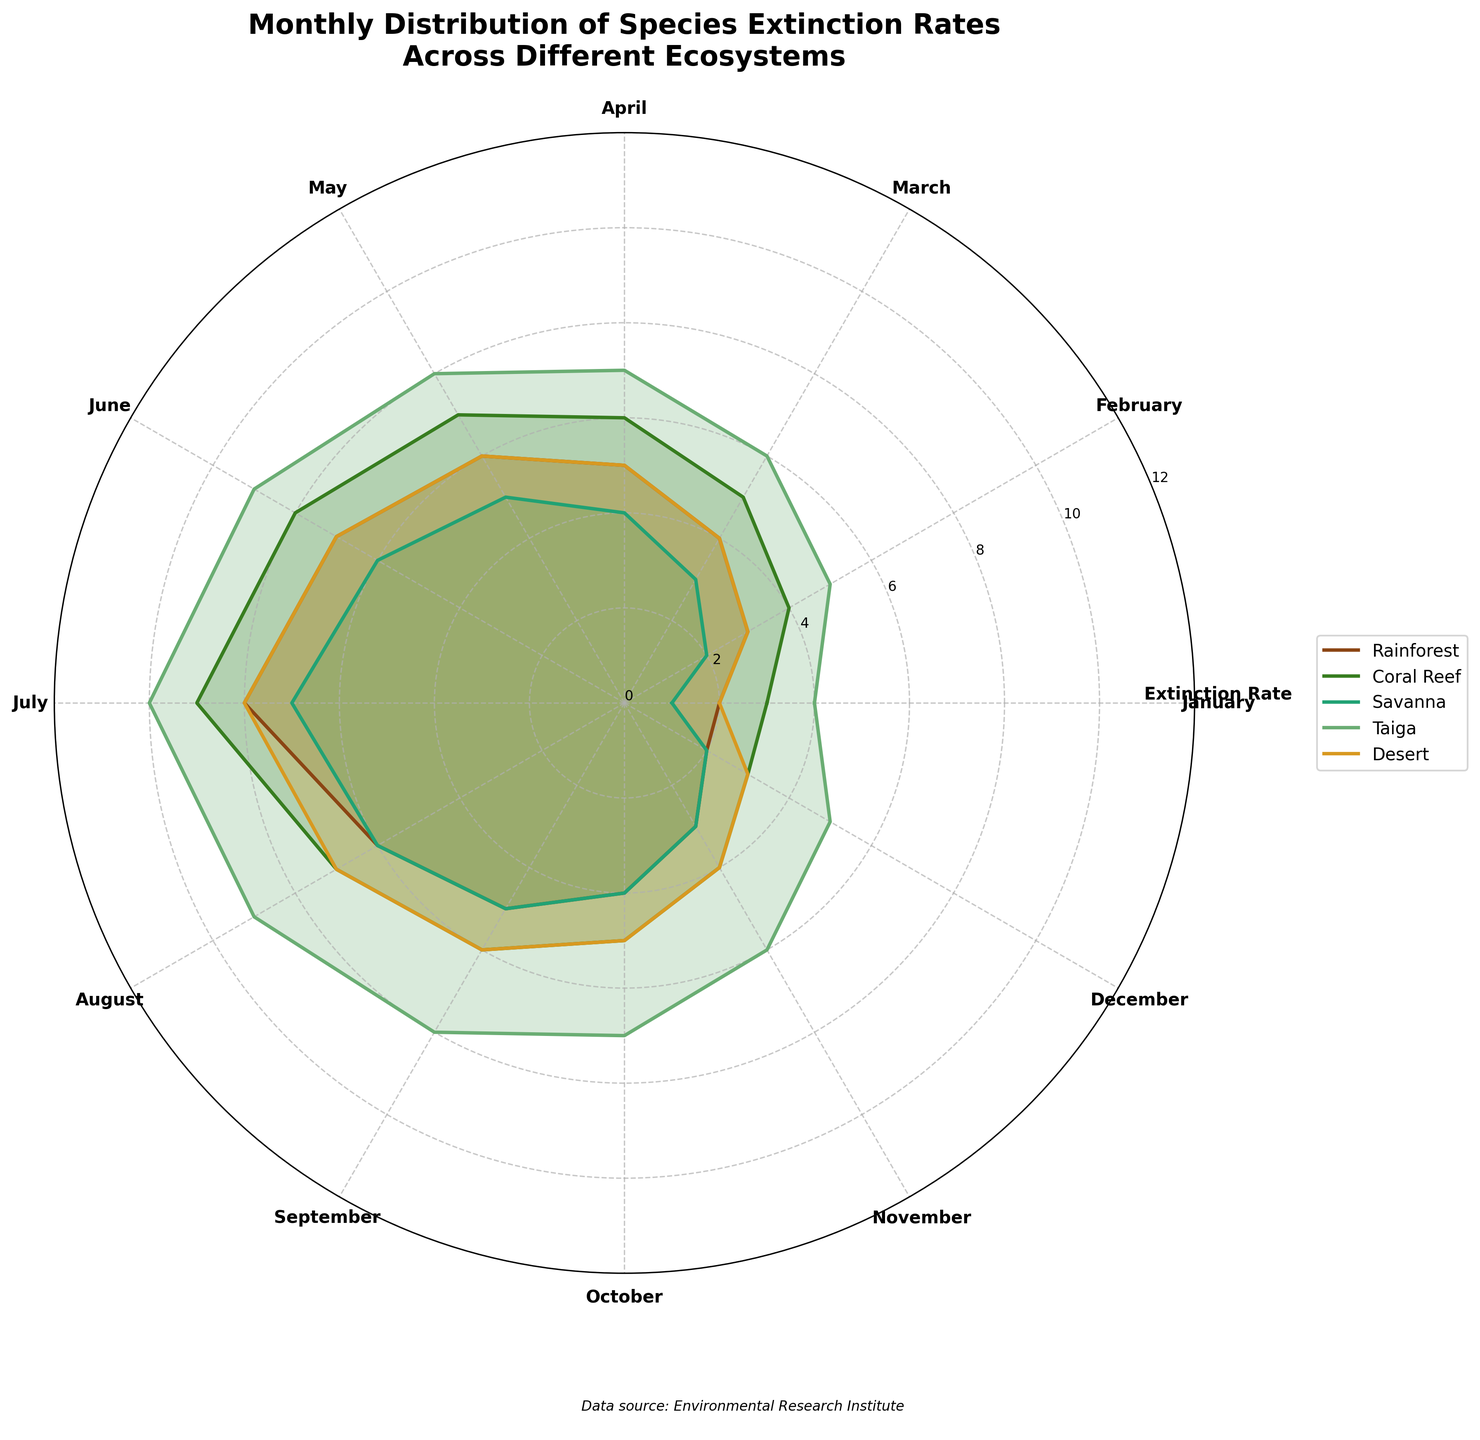What is the title of the figure? The title is typically found at the top of the figure and provides a broad description of what the graph represents. In this case, it is about the monthly distribution of species extinction rates across different ecosystems.
Answer: Monthly Distribution of Species Extinction Rates Across Different Ecosystems What is the maximum extinction rate recorded for the Taiga ecosystem? Look for the Taiga data series on the rose chart and identify the highest point on the radial axis. The maximum value represents the highest extinction rate.
Answer: 10 Which ecosystem has the lowest extinction rate in January? Compare the data points for January across all ecosystems. The ecosystem with the smallest radial extent in January has the lowest extinction rate.
Answer: Savanna In which month do both Rainforest and Coral Reef ecosystems show the same extinction rate? Compare the lines or filled areas for both Rainforest and Coral Reef ecosystems across all months and note if any intersect or overlap at the same radial distance from the center.
Answer: December What's the average extinction rate for the Rainforest ecosystem over the year? To find the average, sum the extinction rates for the Rainforest ecosystem across all months and divide by 12 (the number of months). The calculation is (2 + 3 + 4 + 5 + 6 + 7 + 8 + 6 + 5 + 4 + 3 + 2) / 12.
Answer: 4.75 In which month is the extinction rate highest for all ecosystems combined? For this, you would identify the month where the combined radial extents of all ecosystems are collectively the largest on the plot. Highest extinction rates are typically shown with the largest aggregate visual representations.
Answer: July Which ecosystem shows the greatest fluctuating extinction rates throughout the year? Compare the range of extinction rates for each ecosystem by looking at the difference between their maximum and minimum values. The ecosystem with the widest spread indicates the greatest fluctuation.
Answer: Taiga How do the extinction rates in Coral Reefs and Savannas compare in April? Observe the data points for both Coral Reef and Savanna ecosystems in April. Compare the radial extents to see which one is larger or if they are equal.
Answer: Coral Reef is higher Which ecosystem shows a peak extinction rate in June? Identify the highest points on the radial axis for the month of June and then determine which ecosystem they correspond to. Look for the point that extends the furthest.
Answer: Taiga 